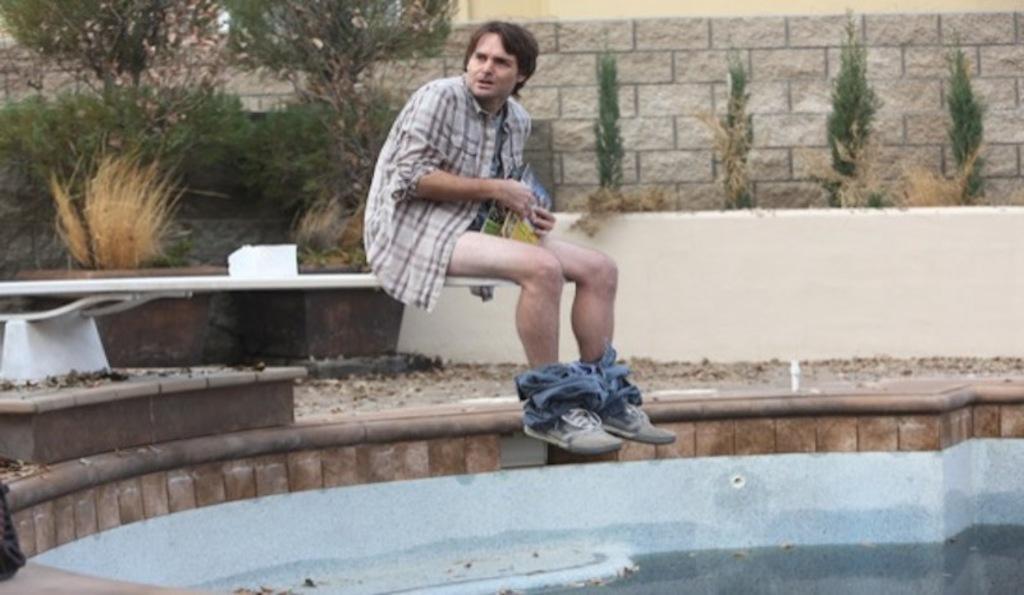Describe this image in one or two sentences. There is water in the pool. A man is sitting wearing a shirt and holding a book. There are plants and a brick wall at the back. 